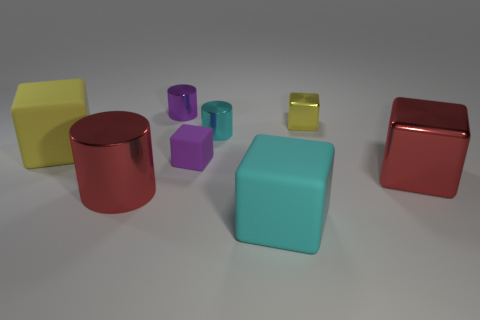There is a cyan object that is on the right side of the small cyan cylinder; is it the same shape as the small purple matte thing?
Keep it short and to the point. Yes. There is a tiny yellow thing that is the same shape as the tiny purple rubber object; what is it made of?
Give a very brief answer. Metal. What number of objects are either purple objects that are on the right side of the purple metallic cylinder or small objects behind the tiny purple cube?
Provide a succinct answer. 4. There is a large shiny cylinder; does it have the same color as the large rubber block that is to the left of the purple rubber cube?
Make the answer very short. No. The big yellow object that is the same material as the small purple block is what shape?
Provide a short and direct response. Cube. How many red metal spheres are there?
Offer a very short reply. 0. How many objects are shiny blocks that are to the left of the large red metal block or blue metallic objects?
Ensure brevity in your answer.  1. There is a large block behind the small purple matte block; is its color the same as the tiny metal block?
Offer a terse response. Yes. What number of other objects are there of the same color as the big metallic block?
Provide a succinct answer. 1. How many large objects are rubber blocks or yellow things?
Ensure brevity in your answer.  2. 